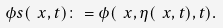Convert formula to latex. <formula><loc_0><loc_0><loc_500><loc_500>\phi s ( \ x , t ) \colon = \phi ( \ x , \eta ( \ x , t ) , t ) .</formula> 